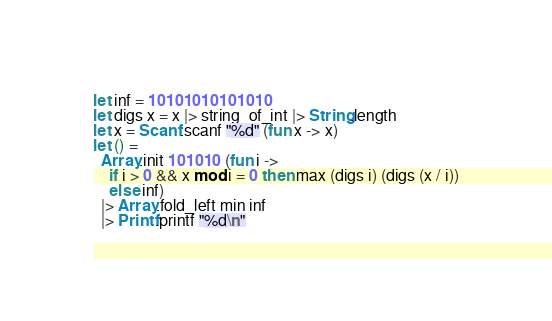<code> <loc_0><loc_0><loc_500><loc_500><_OCaml_>let inf = 10101010101010
let digs x = x |> string_of_int |> String.length
let x = Scanf.scanf "%d" (fun x -> x)
let () =
  Array.init 101010 (fun i ->
    if i > 0 && x mod i = 0 then max (digs i) (digs (x / i))
    else inf)
  |> Array.fold_left min inf
  |> Printf.printf "%d\n"
</code> 